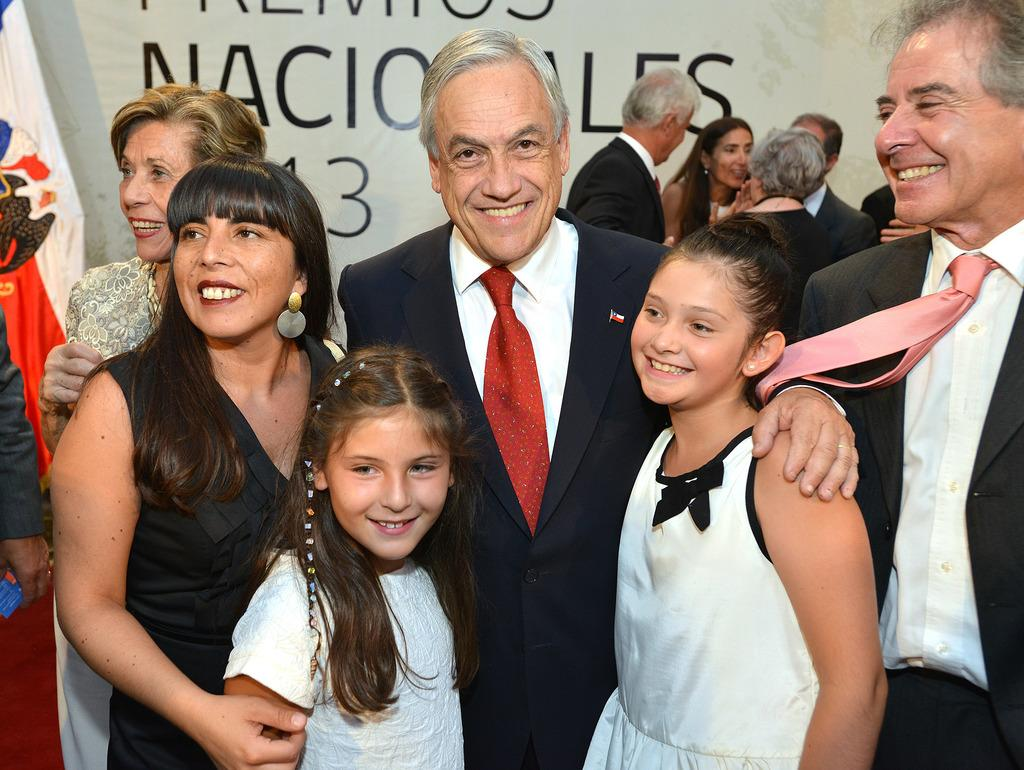How many people are in the center of the image? There are multiple persons standing in the center of the image. What is the surface on which the persons are standing? The persons are standing on the floor. What can be seen in the background of the image? There is a wall visible in the background of the image. What type of song is being played in the background of the image? There is no indication of any song being played in the image; it only shows multiple persons standing on the floor with a wall visible in the background. 